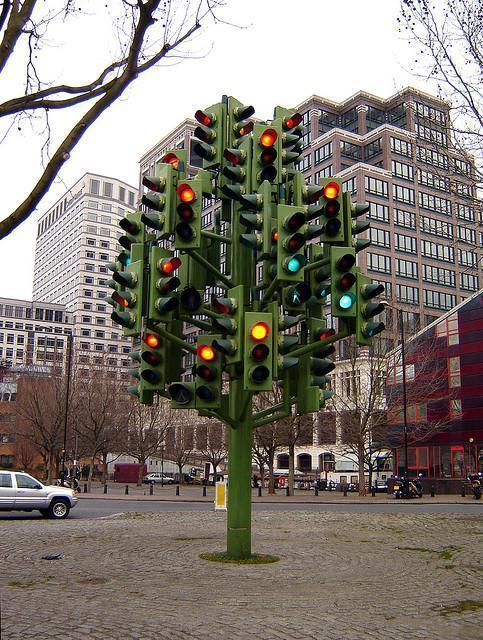How many traffic lights are visible?
Give a very brief answer. 5. 